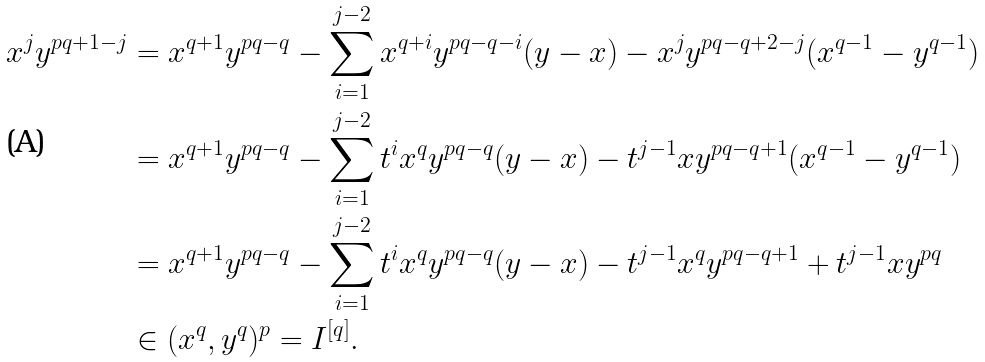<formula> <loc_0><loc_0><loc_500><loc_500>x ^ { j } y ^ { p q + 1 - j } & = x ^ { q + 1 } y ^ { p q - q } - \sum _ { i = 1 } ^ { j - 2 } x ^ { q + i } y ^ { p q - q - i } ( y - x ) - x ^ { j } y ^ { p q - q + 2 - j } ( x ^ { q - 1 } - y ^ { q - 1 } ) \\ & = x ^ { q + 1 } y ^ { p q - q } - \sum _ { i = 1 } ^ { j - 2 } t ^ { i } x ^ { q } y ^ { p q - q } ( y - x ) - t ^ { j - 1 } x y ^ { p q - q + 1 } ( x ^ { q - 1 } - y ^ { q - 1 } ) \\ & = x ^ { q + 1 } y ^ { p q - q } - \sum _ { i = 1 } ^ { j - 2 } t ^ { i } x ^ { q } y ^ { p q - q } ( y - x ) - t ^ { j - 1 } x ^ { q } y ^ { p q - q + 1 } + t ^ { j - 1 } x y ^ { p q } \\ & \in ( x ^ { q } , y ^ { q } ) ^ { p } = I ^ { [ q ] } .</formula> 